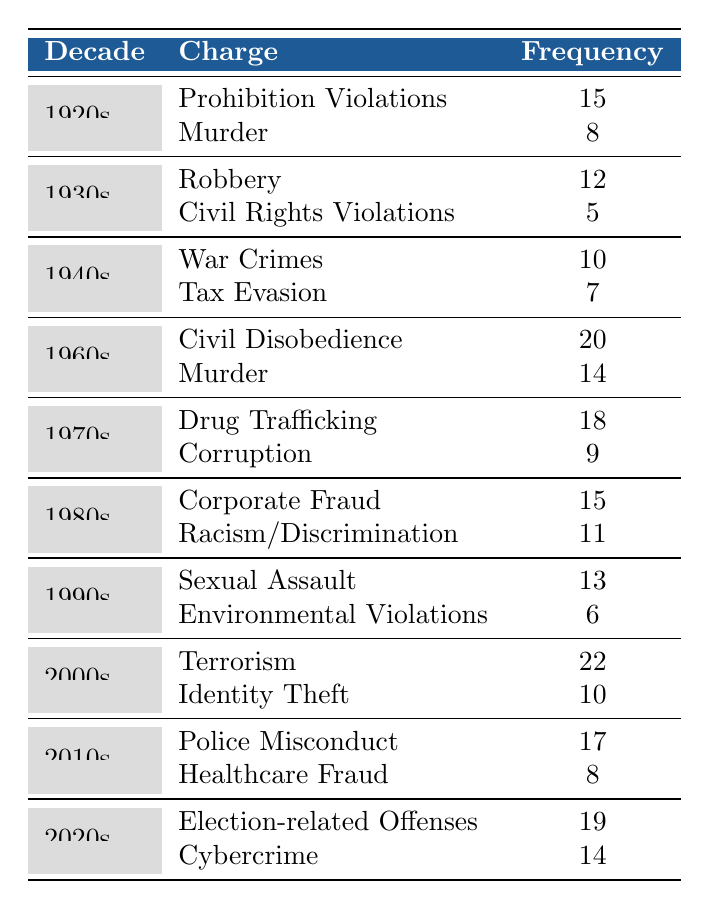What decade had the highest frequency of charges? By examining the frequency column for each decade, we see the following highest frequencies: 1920s has 15, 1930s has 12, 1940s has 10, 1960s has 20, 1970s has 18, 1980s has 15, 1990s has 13, 2000s has 22, 2010s has 17, and 2020s has 19. The highest is found in the 2000s with 22.
Answer: 2000s How many charges were recorded in the 1960s? The table shows two charges in the 1960s: Civil Disobedience (20) and Murder (14). Adding these gives 20 + 14 = 34 charges in total.
Answer: 34 Which charge has the lowest frequency and in which decade? By looking at the frequency for the charges, we note that Civil Rights Violations has the lowest frequency of 5, recorded in the 1930s.
Answer: Civil Rights Violations in the 1930s What is the total frequency of drug-related charges across decades? In the table, Drug Trafficking in the 1970s has a frequency of 18, and the only other drug-related charges are not present. Hence, the total frequency only includes Drug Trafficking which is 18.
Answer: 18 Did any decade have charges related to both Prohibition Violations and Murder? The 1920s is the only decade that lists both Prohibition Violations (15) and Murder (8) as charges.
Answer: Yes What is the average frequency of charges in the 2010s? In the 2010s, there are two charges: Police Misconduct (17) and Healthcare Fraud (8). We sum these frequencies: 17 + 8 = 25. Since there are 2 charges, the average is 25 / 2 = 12.5.
Answer: 12.5 Which decade experienced the largest number of charges related to Civil Rights Violations? Civil Rights Violations are only noted in the 1930s, with a frequency of 5. Therefore, it is the only decade that had this specific charge.
Answer: 1930s What was the combined frequency of charges in the 1980s? In the 1980s, the charges are Corporate Fraud (15) and Racism/Discrimination (11). Adding these: 15 + 11 = 26 gives the total frequency for that decade.
Answer: 26 How does the frequency of charges in the 2020s compare to the frequency in the 1990s? The 2020s has Election-related Offenses (19) and Cybercrime (14), totaling 19 + 14 = 33. The 1990s has Sexual Assault (13) and Environmental Violations (6), totaling 13 + 6 = 19. Comparing: 33 > 19.
Answer: 2020s has higher frequency 